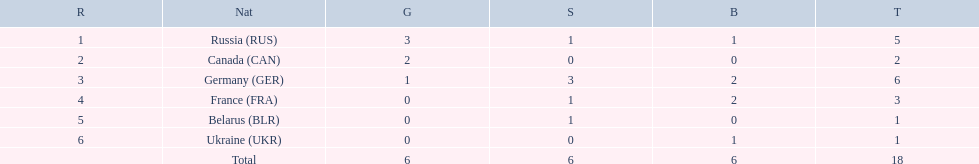What are all the countries in the 1994 winter olympics biathlon? Russia (RUS), Canada (CAN), Germany (GER), France (FRA), Belarus (BLR), Ukraine (UKR). Which of these received at least one gold medal? Russia (RUS), Canada (CAN), Germany (GER). Which of these received no silver or bronze medals? Canada (CAN). 